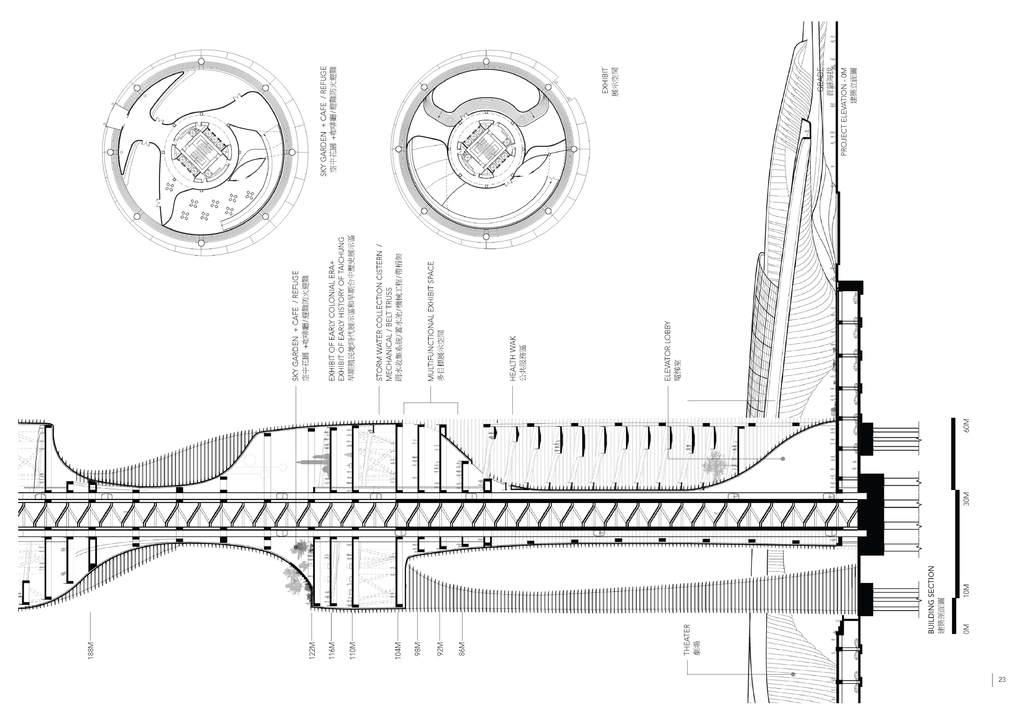What can be seen in the image that is not written language? There are drawings in the image that are not written language. What is the other type of content present in the image? There is text in the image. How many eggs are visible in the image? There are no eggs present in the image. What type of furniture is shown in the image? The provided facts do not mention any furniture, including a desk, in the image. 